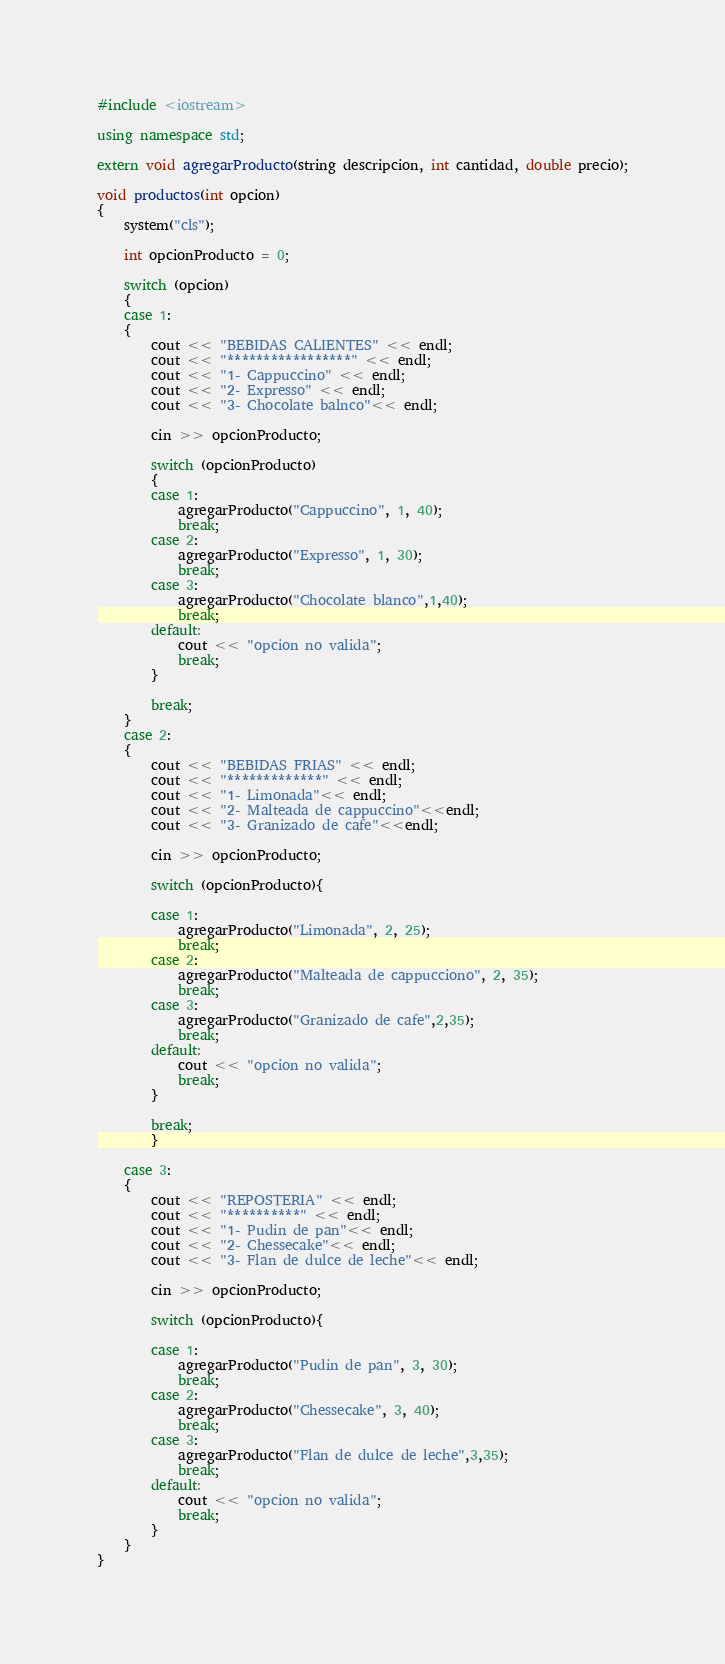<code> <loc_0><loc_0><loc_500><loc_500><_C++_>#include <iostream>

using namespace std;

extern void agregarProducto(string descripcion, int cantidad, double precio);

void productos(int opcion)
{
    system("cls");

    int opcionProducto = 0;

    switch (opcion)
    {
    case 1:
    {
        cout << "BEBIDAS CALIENTES" << endl;
        cout << "*****************" << endl;
        cout << "1- Cappuccino" << endl;
        cout << "2- Expresso" << endl;
        cout << "3- Chocolate balnco"<< endl;

        cin >> opcionProducto;

        switch (opcionProducto)
        {
        case 1:
            agregarProducto("Cappuccino", 1, 40);
            break;
        case 2:
            agregarProducto("Expresso", 1, 30);
            break;
        case 3:
            agregarProducto("Chocolate blanco",1,40);
            break;            
        default:
            cout << "opcion no valida";
            break;
        }
        
        break;
    }
    case 2:
    {
        cout << "BEBIDAS FRIAS" << endl;
        cout << "*************" << endl;
        cout << "1- Limonada"<< endl;
        cout << "2- Malteada de cappuccino"<<endl;
        cout << "3- Granizado de cafe"<<endl;

        cin >> opcionProducto;

        switch (opcionProducto){

        case 1:
            agregarProducto("Limonada", 2, 25);
            break;
        case 2:
            agregarProducto("Malteada de cappucciono", 2, 35);
            break;
        case 3:
            agregarProducto("Granizado de cafe",2,35);
            break;            
        default:
            cout << "opcion no valida";
            break;
        }
        
        break;
        }

    case 3:
    {
        cout << "REPOSTERIA" << endl;
        cout << "**********" << endl;
        cout << "1- Pudin de pan"<< endl;
        cout << "2- Chessecake"<< endl;
        cout << "3- Flan de dulce de leche"<< endl;

        cin >> opcionProducto;

        switch (opcionProducto){

        case 1:
            agregarProducto("Pudin de pan", 3, 30);
            break;
        case 2:
            agregarProducto("Chessecake", 3, 40);
            break;
        case 3:
            agregarProducto("Flan de dulce de leche",3,35);
            break;            
        default:
            cout << "opcion no valida";
            break;
        }
    }
}</code> 